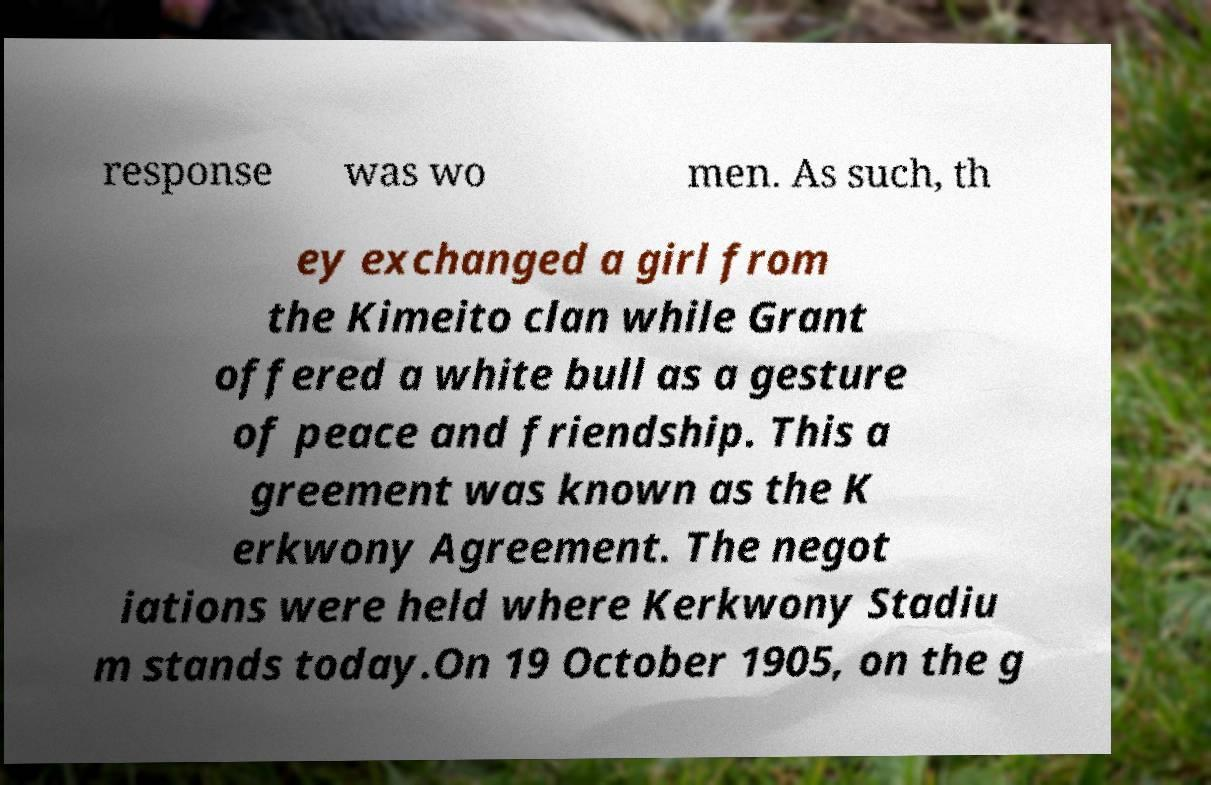There's text embedded in this image that I need extracted. Can you transcribe it verbatim? response was wo men. As such, th ey exchanged a girl from the Kimeito clan while Grant offered a white bull as a gesture of peace and friendship. This a greement was known as the K erkwony Agreement. The negot iations were held where Kerkwony Stadiu m stands today.On 19 October 1905, on the g 